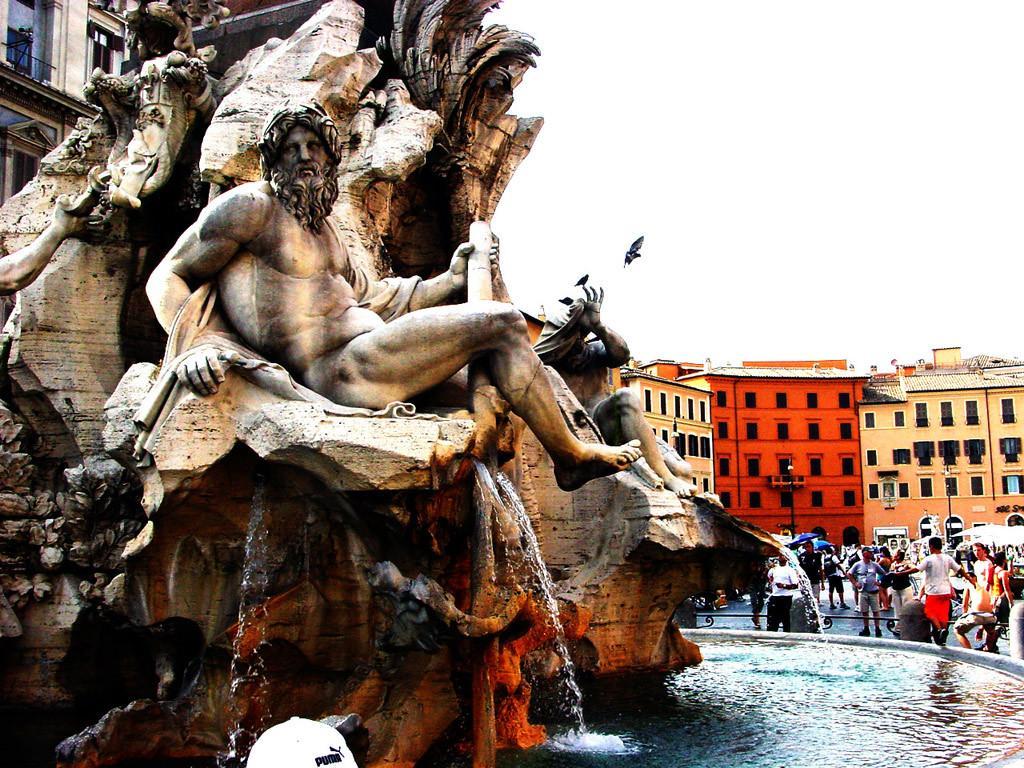Describe this image in one or two sentences. In this image we can see sculptures on the fountain, water, people standing on the road, stalls, street poles, buildings, railings, bird flying in the air and sky. 